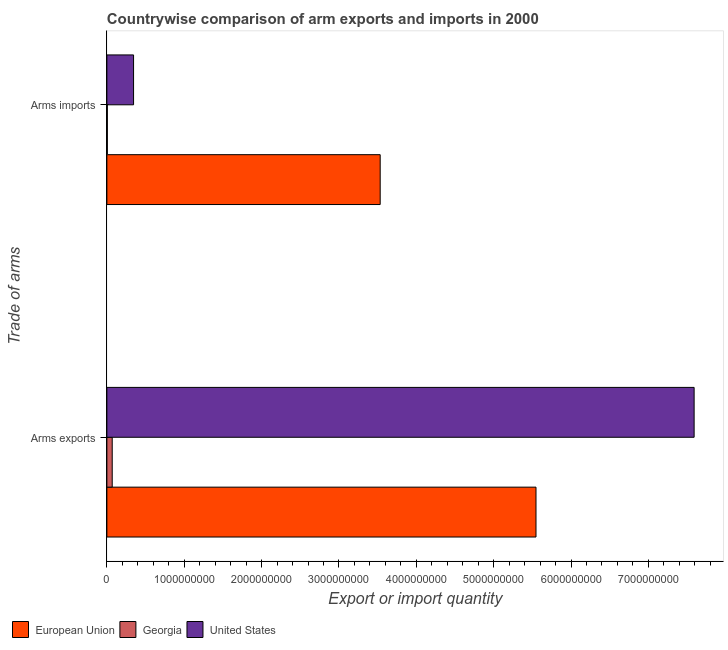How many different coloured bars are there?
Your response must be concise. 3. How many groups of bars are there?
Make the answer very short. 2. How many bars are there on the 1st tick from the top?
Make the answer very short. 3. How many bars are there on the 2nd tick from the bottom?
Make the answer very short. 3. What is the label of the 2nd group of bars from the top?
Offer a terse response. Arms exports. What is the arms imports in Georgia?
Make the answer very short. 6.00e+06. Across all countries, what is the maximum arms imports?
Give a very brief answer. 3.53e+09. Across all countries, what is the minimum arms exports?
Provide a short and direct response. 6.90e+07. In which country was the arms imports minimum?
Offer a terse response. Georgia. What is the total arms imports in the graph?
Offer a very short reply. 3.88e+09. What is the difference between the arms imports in United States and that in European Union?
Provide a succinct answer. -3.19e+09. What is the difference between the arms imports in United States and the arms exports in Georgia?
Provide a short and direct response. 2.76e+08. What is the average arms imports per country?
Your response must be concise. 1.29e+09. What is the difference between the arms exports and arms imports in Georgia?
Provide a short and direct response. 6.30e+07. What is the ratio of the arms exports in United States to that in European Union?
Provide a short and direct response. 1.37. What does the 1st bar from the top in Arms exports represents?
Offer a very short reply. United States. How many bars are there?
Give a very brief answer. 6. Does the graph contain grids?
Your answer should be very brief. No. Where does the legend appear in the graph?
Your answer should be very brief. Bottom left. What is the title of the graph?
Provide a short and direct response. Countrywise comparison of arm exports and imports in 2000. Does "Mali" appear as one of the legend labels in the graph?
Your response must be concise. No. What is the label or title of the X-axis?
Your answer should be compact. Export or import quantity. What is the label or title of the Y-axis?
Offer a very short reply. Trade of arms. What is the Export or import quantity of European Union in Arms exports?
Your response must be concise. 5.55e+09. What is the Export or import quantity in Georgia in Arms exports?
Keep it short and to the point. 6.90e+07. What is the Export or import quantity of United States in Arms exports?
Your response must be concise. 7.59e+09. What is the Export or import quantity of European Union in Arms imports?
Give a very brief answer. 3.53e+09. What is the Export or import quantity in United States in Arms imports?
Your answer should be compact. 3.45e+08. Across all Trade of arms, what is the maximum Export or import quantity of European Union?
Give a very brief answer. 5.55e+09. Across all Trade of arms, what is the maximum Export or import quantity of Georgia?
Your answer should be very brief. 6.90e+07. Across all Trade of arms, what is the maximum Export or import quantity of United States?
Your response must be concise. 7.59e+09. Across all Trade of arms, what is the minimum Export or import quantity of European Union?
Your response must be concise. 3.53e+09. Across all Trade of arms, what is the minimum Export or import quantity in Georgia?
Offer a terse response. 6.00e+06. Across all Trade of arms, what is the minimum Export or import quantity in United States?
Your response must be concise. 3.45e+08. What is the total Export or import quantity of European Union in the graph?
Keep it short and to the point. 9.08e+09. What is the total Export or import quantity in Georgia in the graph?
Make the answer very short. 7.50e+07. What is the total Export or import quantity of United States in the graph?
Your answer should be compact. 7.94e+09. What is the difference between the Export or import quantity of European Union in Arms exports and that in Arms imports?
Make the answer very short. 2.01e+09. What is the difference between the Export or import quantity of Georgia in Arms exports and that in Arms imports?
Offer a very short reply. 6.30e+07. What is the difference between the Export or import quantity of United States in Arms exports and that in Arms imports?
Provide a short and direct response. 7.25e+09. What is the difference between the Export or import quantity in European Union in Arms exports and the Export or import quantity in Georgia in Arms imports?
Keep it short and to the point. 5.54e+09. What is the difference between the Export or import quantity of European Union in Arms exports and the Export or import quantity of United States in Arms imports?
Your answer should be very brief. 5.20e+09. What is the difference between the Export or import quantity of Georgia in Arms exports and the Export or import quantity of United States in Arms imports?
Make the answer very short. -2.76e+08. What is the average Export or import quantity of European Union per Trade of arms?
Keep it short and to the point. 4.54e+09. What is the average Export or import quantity in Georgia per Trade of arms?
Provide a succinct answer. 3.75e+07. What is the average Export or import quantity in United States per Trade of arms?
Offer a very short reply. 3.97e+09. What is the difference between the Export or import quantity in European Union and Export or import quantity in Georgia in Arms exports?
Provide a succinct answer. 5.48e+09. What is the difference between the Export or import quantity in European Union and Export or import quantity in United States in Arms exports?
Keep it short and to the point. -2.04e+09. What is the difference between the Export or import quantity of Georgia and Export or import quantity of United States in Arms exports?
Your answer should be compact. -7.52e+09. What is the difference between the Export or import quantity of European Union and Export or import quantity of Georgia in Arms imports?
Offer a very short reply. 3.53e+09. What is the difference between the Export or import quantity of European Union and Export or import quantity of United States in Arms imports?
Give a very brief answer. 3.19e+09. What is the difference between the Export or import quantity in Georgia and Export or import quantity in United States in Arms imports?
Make the answer very short. -3.39e+08. What is the ratio of the Export or import quantity in European Union in Arms exports to that in Arms imports?
Your answer should be very brief. 1.57. What is the ratio of the Export or import quantity in Georgia in Arms exports to that in Arms imports?
Your answer should be very brief. 11.5. What is the ratio of the Export or import quantity of United States in Arms exports to that in Arms imports?
Make the answer very short. 22. What is the difference between the highest and the second highest Export or import quantity of European Union?
Give a very brief answer. 2.01e+09. What is the difference between the highest and the second highest Export or import quantity in Georgia?
Offer a terse response. 6.30e+07. What is the difference between the highest and the second highest Export or import quantity in United States?
Keep it short and to the point. 7.25e+09. What is the difference between the highest and the lowest Export or import quantity in European Union?
Your answer should be very brief. 2.01e+09. What is the difference between the highest and the lowest Export or import quantity in Georgia?
Give a very brief answer. 6.30e+07. What is the difference between the highest and the lowest Export or import quantity of United States?
Give a very brief answer. 7.25e+09. 